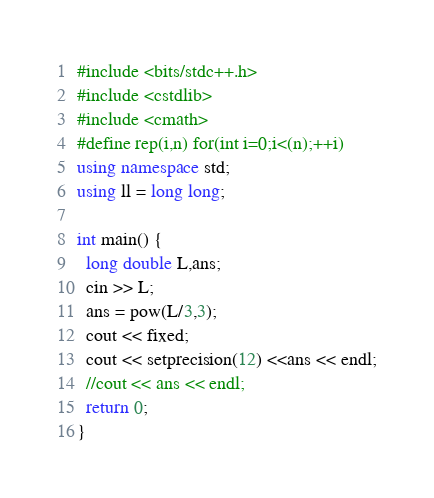<code> <loc_0><loc_0><loc_500><loc_500><_C++_>#include <bits/stdc++.h>
#include <cstdlib>
#include <cmath>
#define rep(i,n) for(int i=0;i<(n);++i)
using namespace std;
using ll = long long;

int main() {
  long double L,ans;
  cin >> L;
  ans = pow(L/3,3);
  cout << fixed;
  cout << setprecision(12) <<ans << endl;
  //cout << ans << endl;
  return 0;
}</code> 